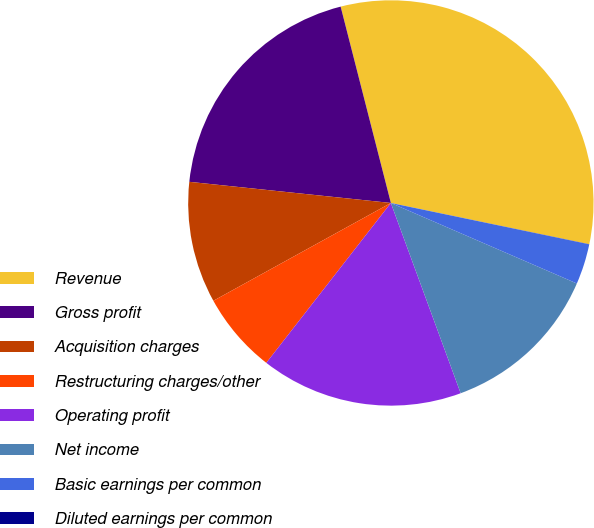Convert chart to OTSL. <chart><loc_0><loc_0><loc_500><loc_500><pie_chart><fcel>Revenue � � � � � � � � � � �<fcel>Gross profit � � � � � � � � �<fcel>Acquisition charges � � � � �<fcel>Restructuring charges/other �<fcel>Operating profit� � � � � � �<fcel>Net income � � � � � � � � � �<fcel>Basic earnings per common<fcel>Diluted earnings per common<nl><fcel>32.25%<fcel>19.35%<fcel>9.68%<fcel>6.45%<fcel>16.13%<fcel>12.9%<fcel>3.23%<fcel>0.01%<nl></chart> 